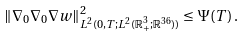Convert formula to latex. <formula><loc_0><loc_0><loc_500><loc_500>\| \nabla _ { 0 } \nabla _ { 0 } \nabla w \| ^ { 2 } _ { L ^ { 2 } ( 0 , T ; L ^ { 2 } ( { \mathbb { R } } ^ { 3 } _ { + } ; { \mathbb { R } } ^ { 3 6 } ) ) } \leq \Psi ( T ) \, .</formula> 